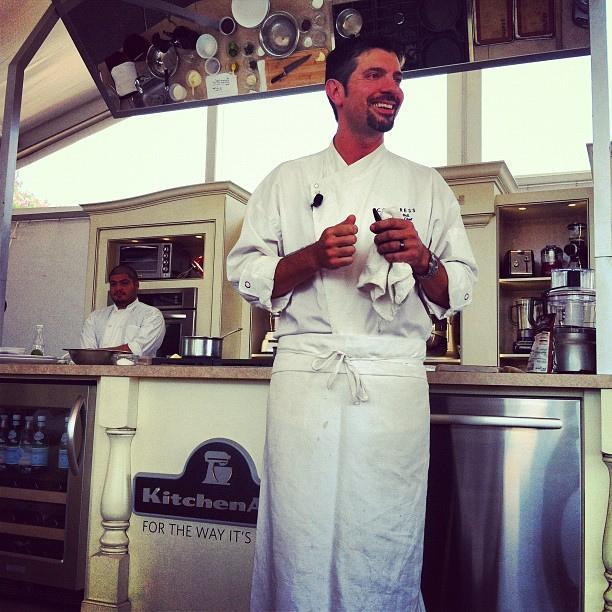How many people are there?
Give a very brief answer. 2. 